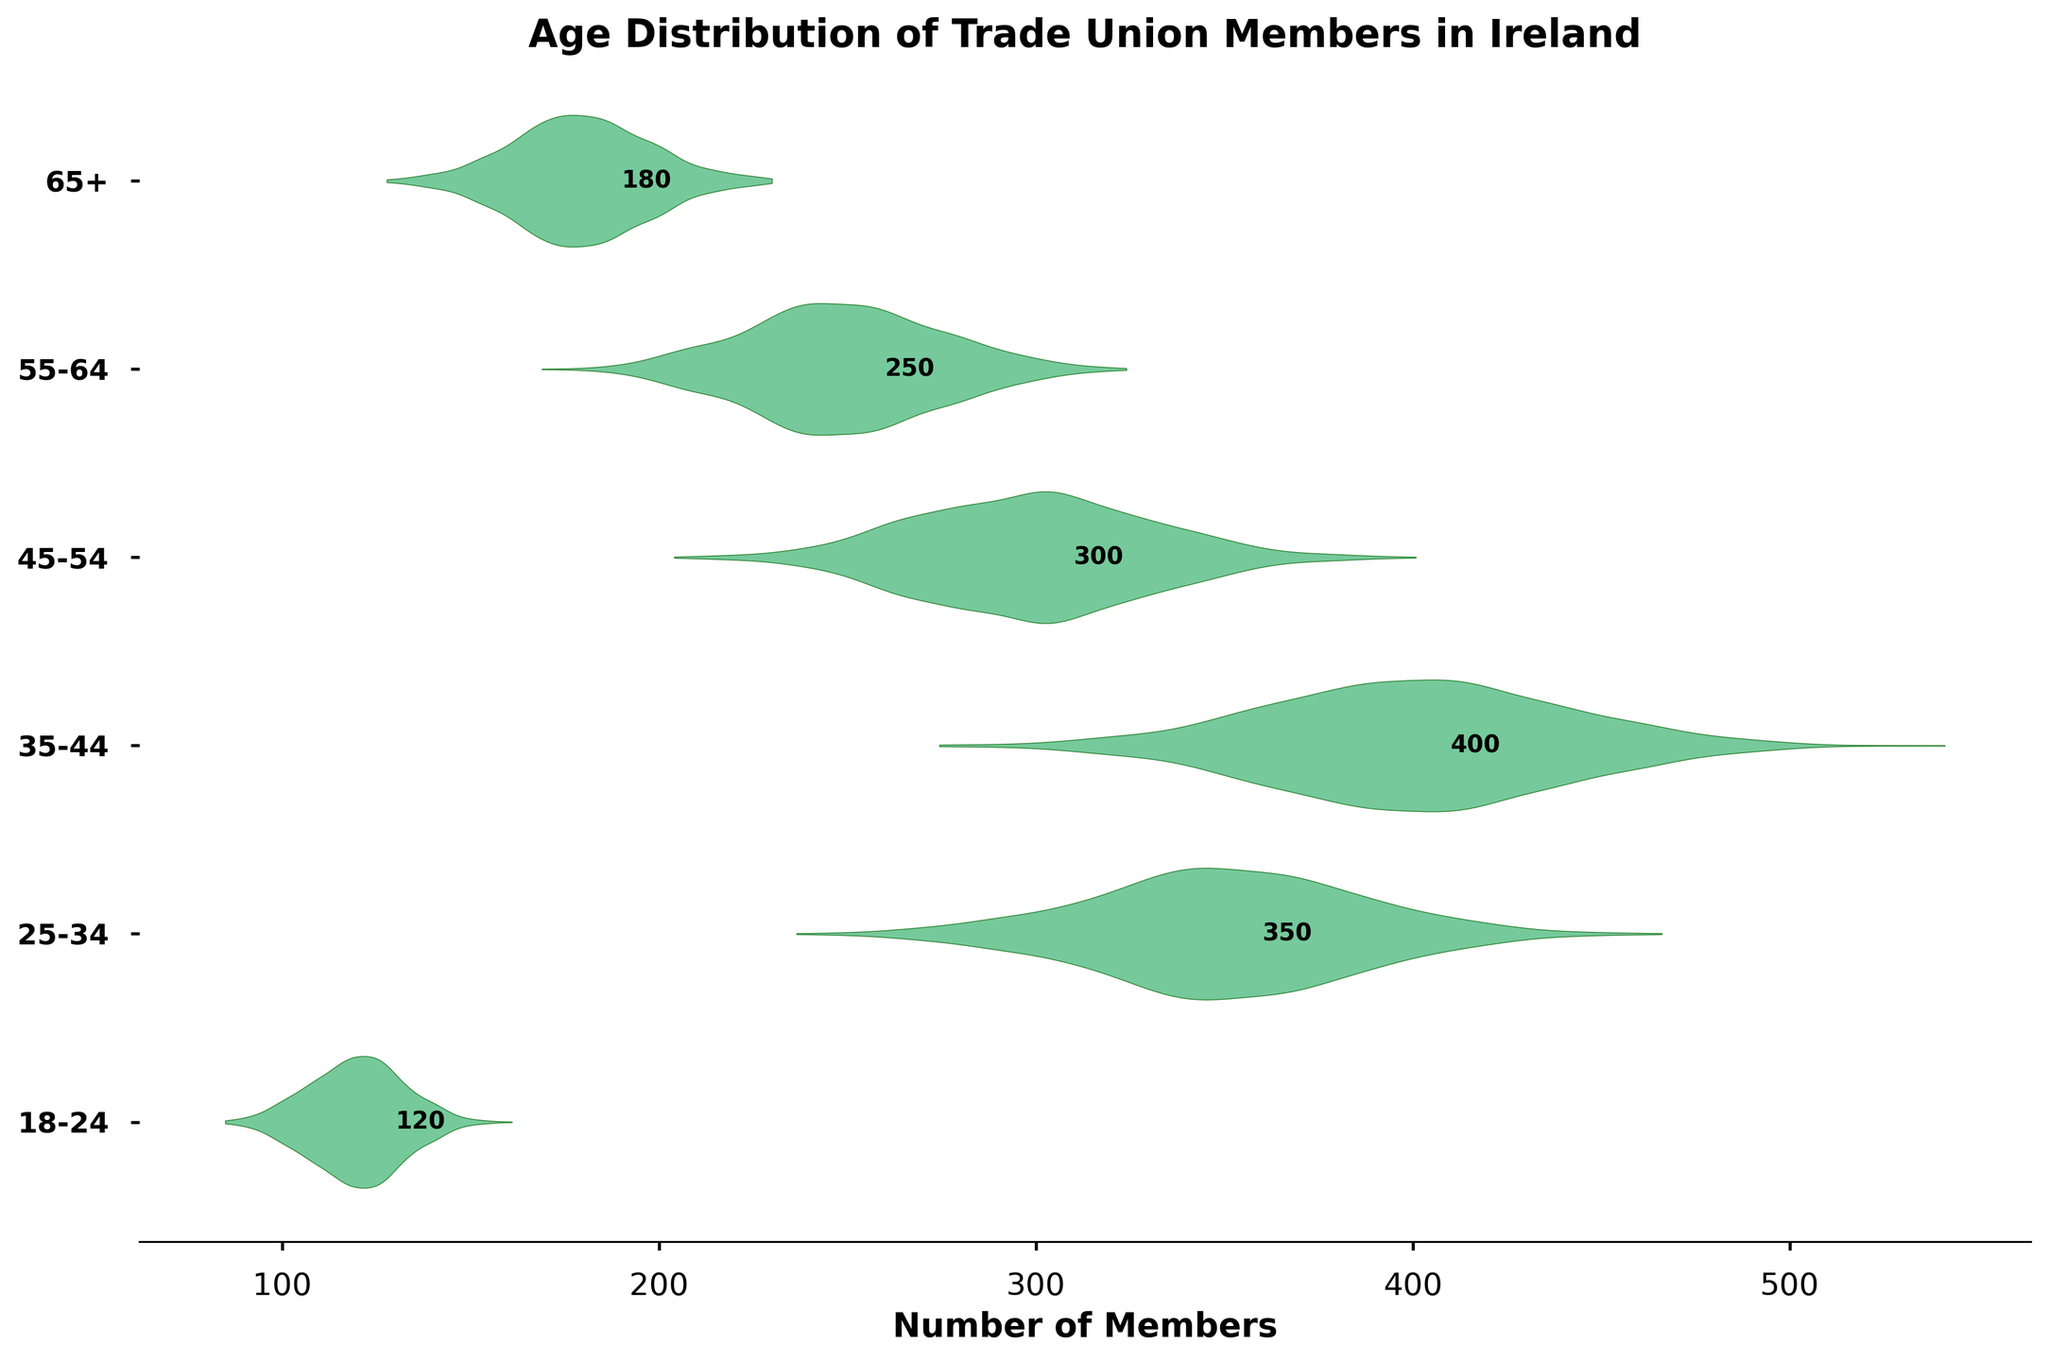What's the title of the chart? The title of the chart is shown at the top and provides a brief summary of what the chart represents. In this case, it helps readers easily understand the context and content of the data visualization.
Answer: Age Distribution of Trade Union Members in Ireland What does the x-axis represent? The x-axis labels indicate the parameter being measured or compared in the chart. In this chart, the x-axis represents the number of members in each age group.
Answer: Number of Members Which age group has the highest number of trade union members? By identifying the age group's position on the y-axis and looking at the length of the corresponding violin, the age group with the highest count can be determined. The 35-44 age group has the longest violin.
Answer: 35-44 How many members are in the 18-24 age group? The exact count is marked next to the violin in the chart for clarity. The number next to the 18-24 age group's violin is 120.
Answer: 120 What is the difference in members between the 25-34 and the 55-64 age groups? First, identify the number of members in the 25-34 age group (350) and the 55-64 age group (250). Then subtract the smaller number from the larger number: 350 - 250 = 100.
Answer: 100 What color are the violins in the chart? The violins are a visual element that allow you to see the distribution. In this chart, the violins have a greenish color.
Answer: Green Which age group has the lowest number of members? By assessing the chart, the age group with the shortest or thinnest violin has the lowest number of members. For this chart, the age group 18-24 has the smallest number.
Answer: 18-24 Compare the number of members in the 45-54 age group to the 65+ age group. Which is greater, and by how much? First, find the number of members in each age group: 300 for 45-54 and 180 for 65+. Then, subtract the smaller number from the larger number: 300 - 180 = 120.
Answer: 45-54 by 120 Describe the general trend in the number of members as age increases. By observing the general shape and size of the violins across age groups, you can describe how the number of members changes as age increases. The number of members increases from 18-24 to a peak in the 35-44 age group before decreasing again in older age groups.
Answer: Increases to 35-44, then decreases How might the visual spread around each age group aid in interpreting the data? The spread of the violins indicates the distribution of the data around those age groups. Wider areas of the violin suggest a denser concentration of values around those age levels, offering a more detailed understanding of the member count's variability.
Answer: Shows distribution density 